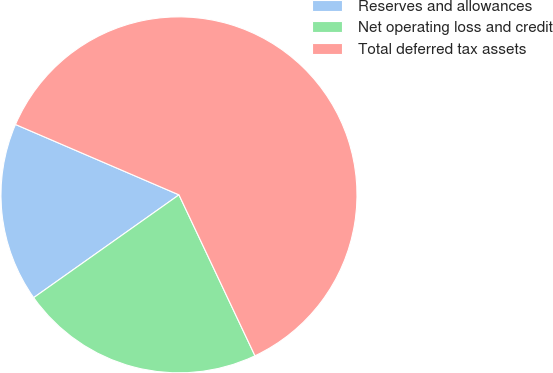Convert chart. <chart><loc_0><loc_0><loc_500><loc_500><pie_chart><fcel>Reserves and allowances<fcel>Net operating loss and credit<fcel>Total deferred tax assets<nl><fcel>16.27%<fcel>22.22%<fcel>61.51%<nl></chart> 